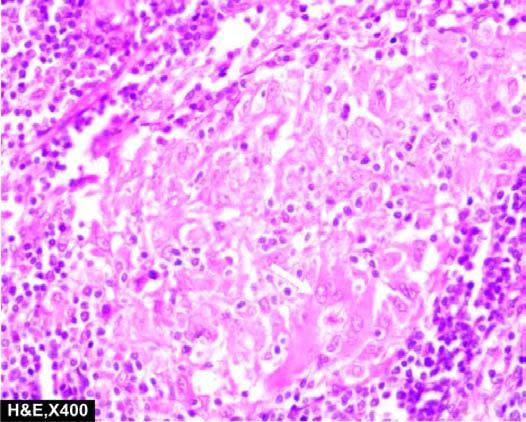what is also seen in the photomicrograph?
Answer the question using a single word or phrase. Giant cell with inclusions 